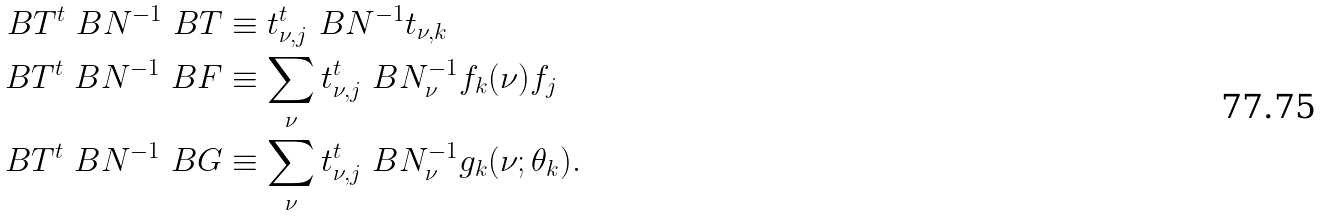Convert formula to latex. <formula><loc_0><loc_0><loc_500><loc_500>\ B T ^ { t } \ B N ^ { - 1 } \ B T & \equiv t ^ { t } _ { \nu , j } \ B N ^ { - 1 } t _ { \nu , k } \\ \ B T ^ { t } \ B N ^ { - 1 } \ B F & \equiv \sum _ { \nu } t ^ { t } _ { \nu , j } \ B N _ { \nu } ^ { - 1 } f _ { k } ( \nu ) f _ { j } \\ \ B T ^ { t } \ B N ^ { - 1 } \ B G & \equiv \sum _ { \nu } t ^ { t } _ { \nu , j } \ B N _ { \nu } ^ { - 1 } g _ { k } ( \nu ; \theta _ { k } ) .</formula> 